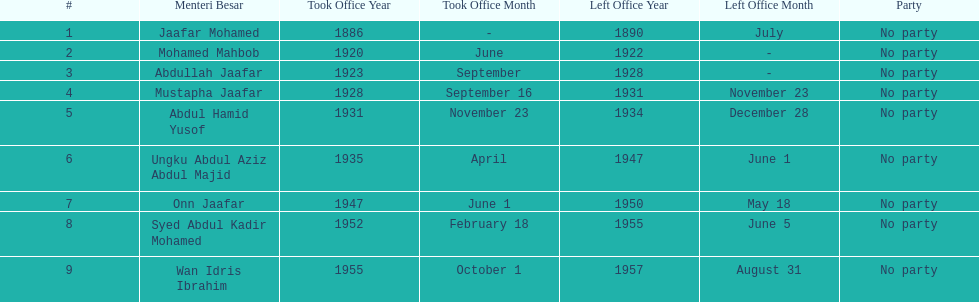Who was in office after mustapha jaafar Abdul Hamid Yusof. 